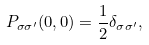<formula> <loc_0><loc_0><loc_500><loc_500>P _ { \sigma \sigma ^ { \prime } } ( 0 , 0 ) = \frac { 1 } { 2 } \delta _ { \sigma \sigma ^ { \prime } } ,</formula> 